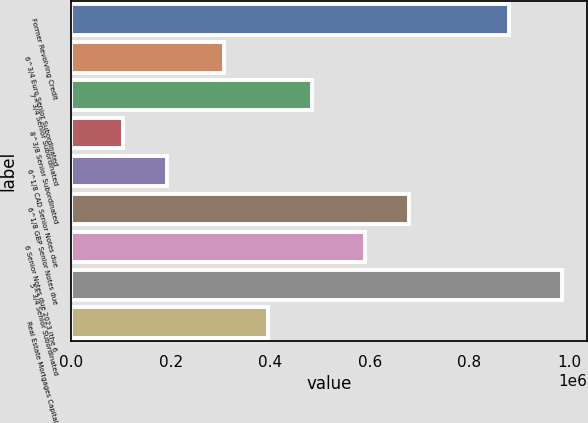Convert chart to OTSL. <chart><loc_0><loc_0><loc_500><loc_500><bar_chart><fcel>Former Revolving Credit<fcel>6^3/4 Euro Senior Subordinated<fcel>7^3/4 Senior Subordinated<fcel>8^3/8 Senior Subordinated<fcel>6^1/8 CAD Senior Notes due<fcel>6^1/8 GBP Senior Notes due<fcel>6 Senior Notes due 2023 (the 6<fcel>5^3/4 Senior Subordinated<fcel>Real Estate Mortgages Capital<nl><fcel>880258<fcel>306799<fcel>483149<fcel>104975<fcel>193150<fcel>678656<fcel>590481<fcel>986725<fcel>394974<nl></chart> 